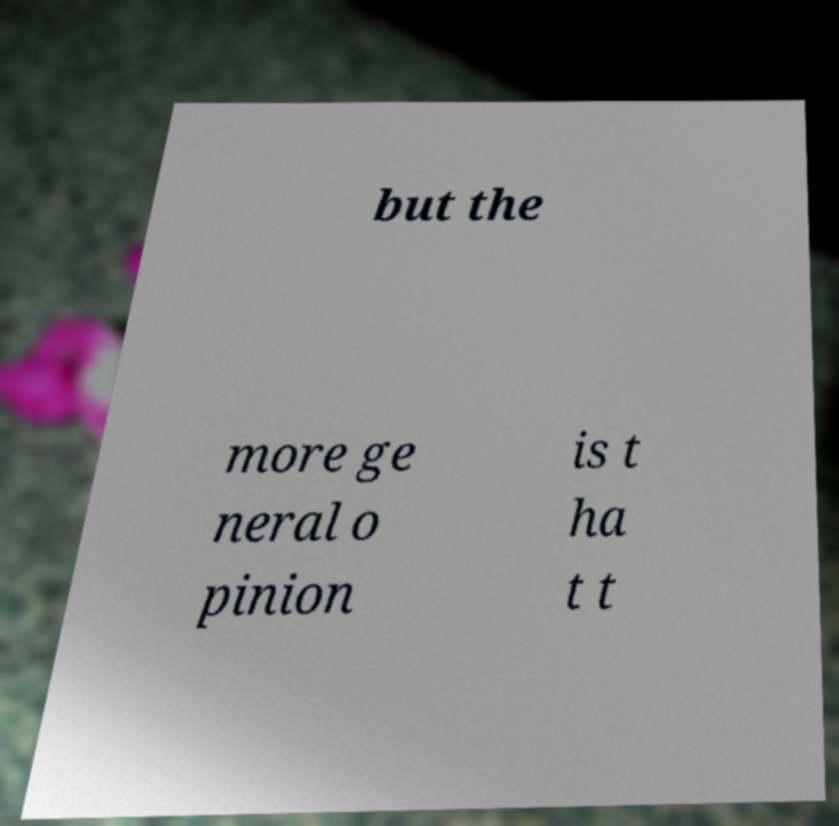I need the written content from this picture converted into text. Can you do that? but the more ge neral o pinion is t ha t t 